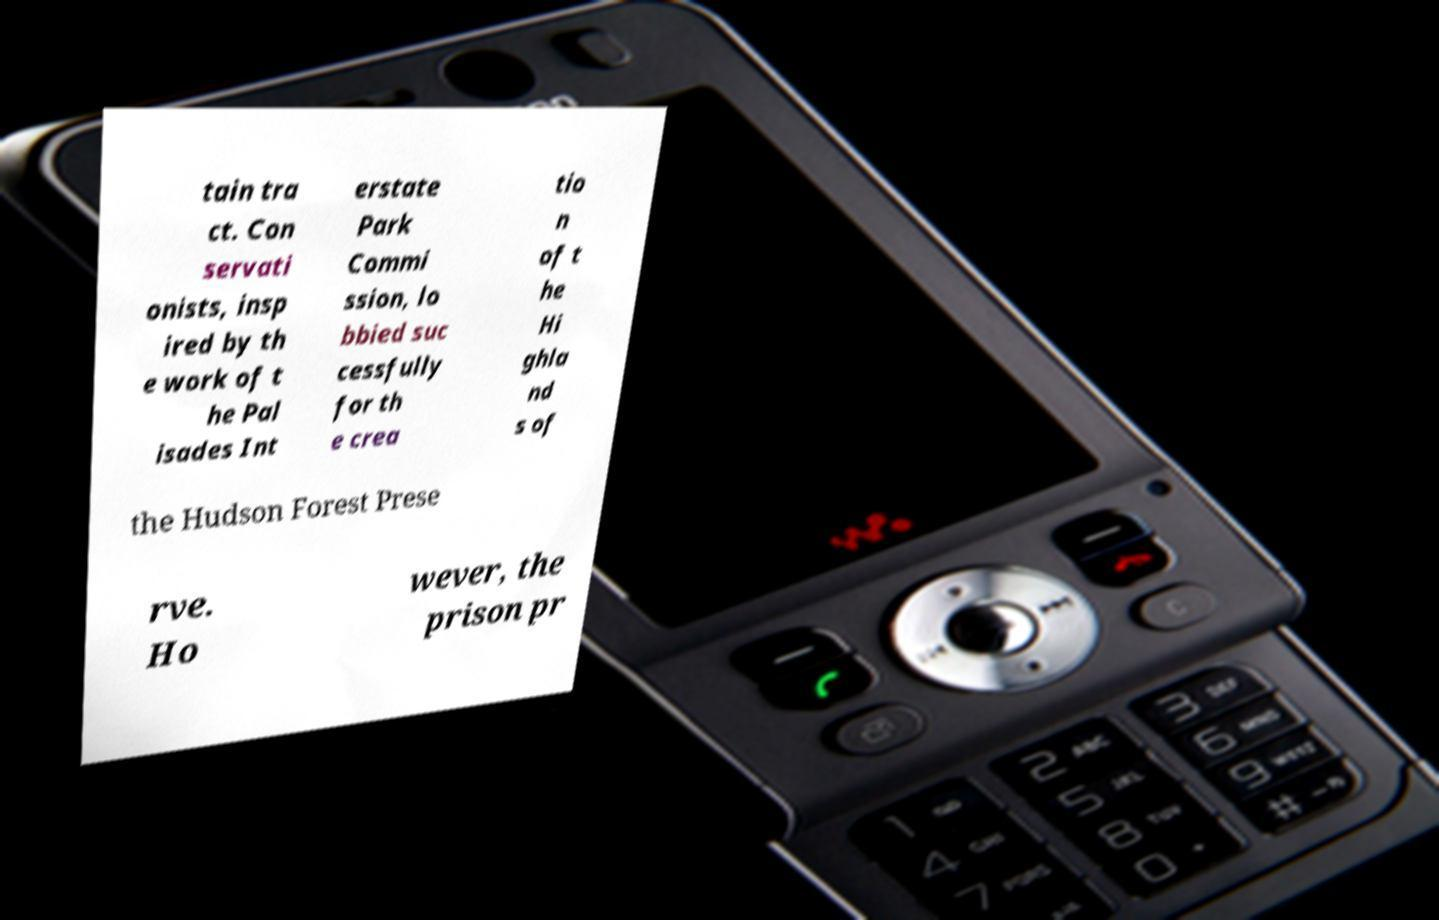For documentation purposes, I need the text within this image transcribed. Could you provide that? tain tra ct. Con servati onists, insp ired by th e work of t he Pal isades Int erstate Park Commi ssion, lo bbied suc cessfully for th e crea tio n of t he Hi ghla nd s of the Hudson Forest Prese rve. Ho wever, the prison pr 